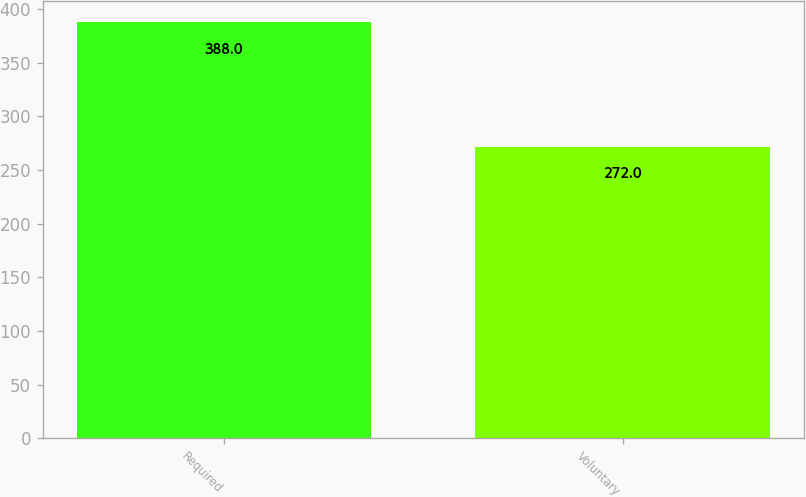<chart> <loc_0><loc_0><loc_500><loc_500><bar_chart><fcel>Required<fcel>Voluntary<nl><fcel>388<fcel>272<nl></chart> 